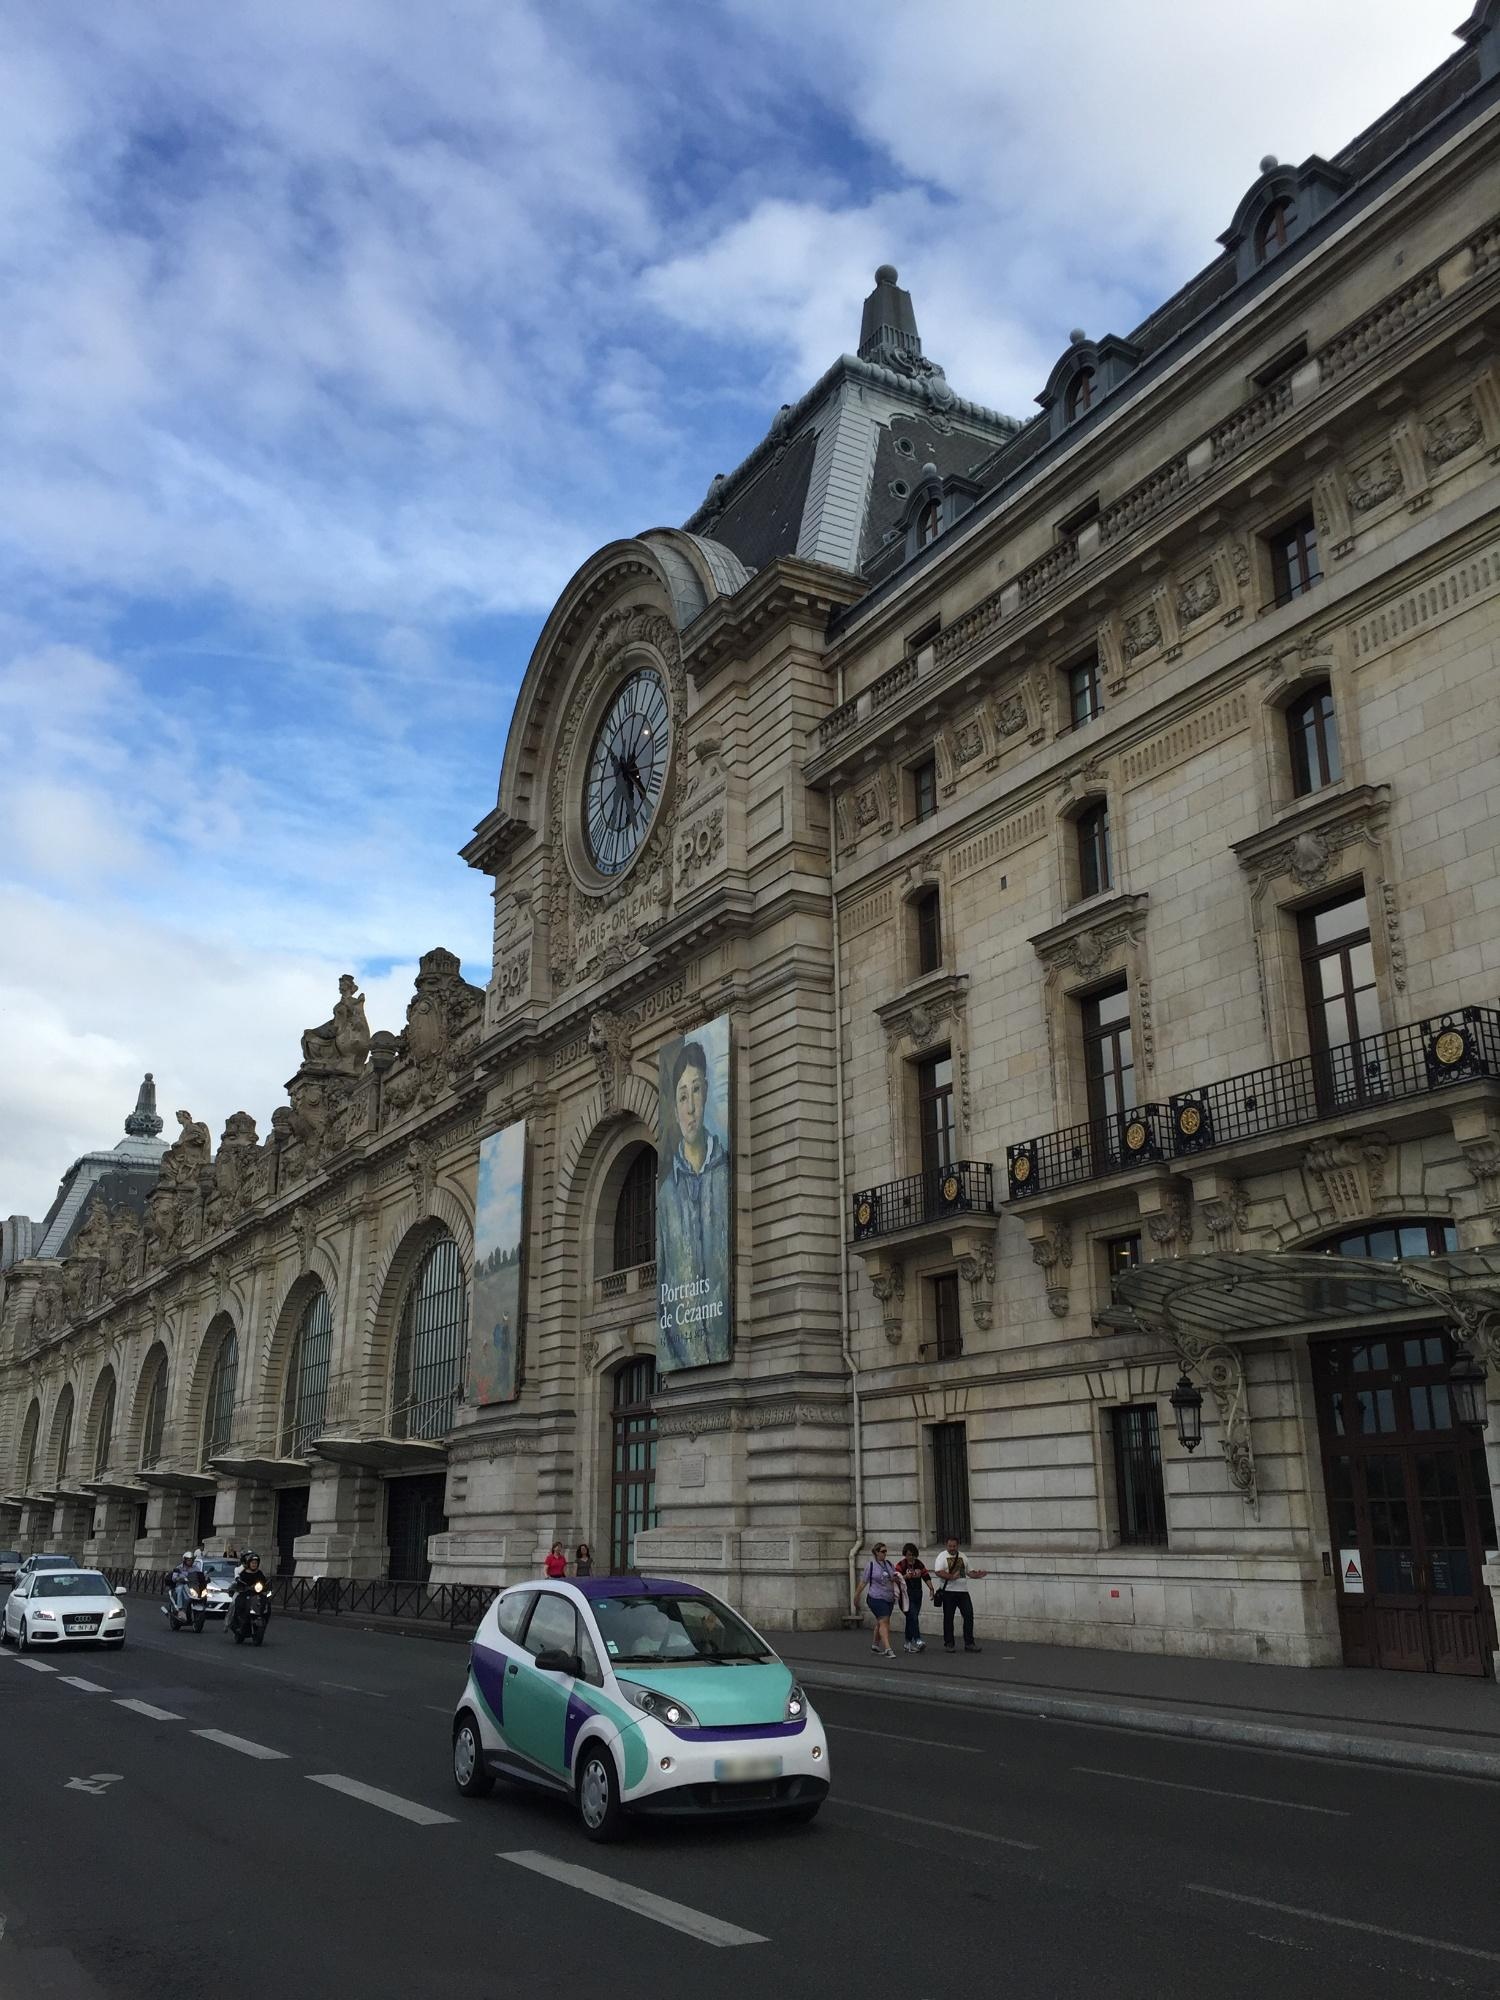What kind of artworks can be found inside this museum? The Musée d'Orsay is renowned for its extensive collection of French art from the period between 1848 and 1914. Inside, you'll find a remarkable assortment of masterpieces including paintings, sculptures, furniture, and photography. It notably houses the world's largest collection of impressionist and post-impressionist paintings, featuring works by celebrated artists like Monet, Manet, Degas, Renoir, Cézanne, and Van Gogh. Visitors can also explore thematic exhibitions that delve into specific art movements, techniques, or artists' oeuvres. 